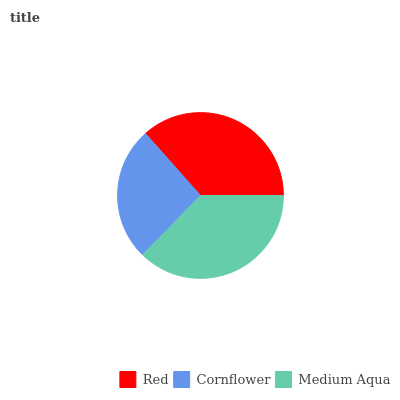Is Cornflower the minimum?
Answer yes or no. Yes. Is Medium Aqua the maximum?
Answer yes or no. Yes. Is Medium Aqua the minimum?
Answer yes or no. No. Is Cornflower the maximum?
Answer yes or no. No. Is Medium Aqua greater than Cornflower?
Answer yes or no. Yes. Is Cornflower less than Medium Aqua?
Answer yes or no. Yes. Is Cornflower greater than Medium Aqua?
Answer yes or no. No. Is Medium Aqua less than Cornflower?
Answer yes or no. No. Is Red the high median?
Answer yes or no. Yes. Is Red the low median?
Answer yes or no. Yes. Is Cornflower the high median?
Answer yes or no. No. Is Medium Aqua the low median?
Answer yes or no. No. 